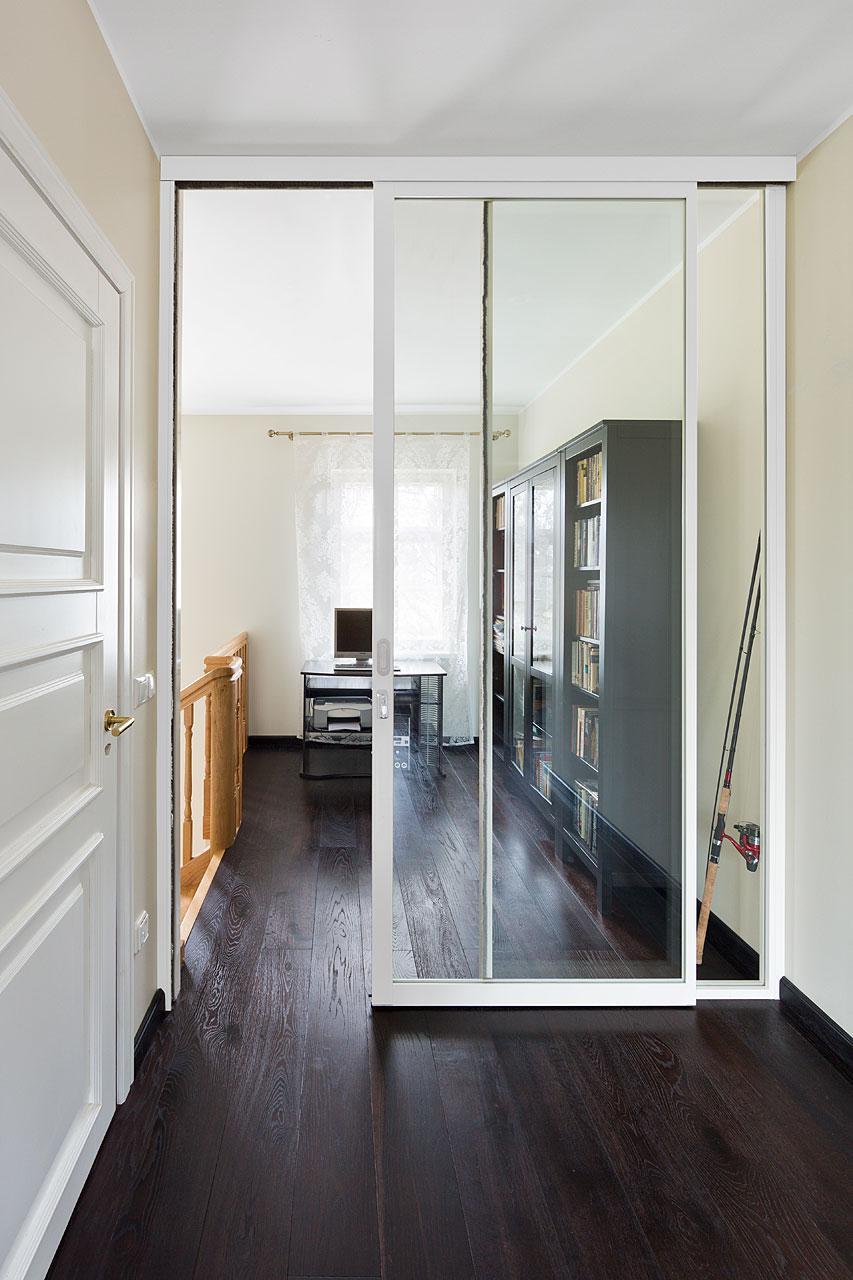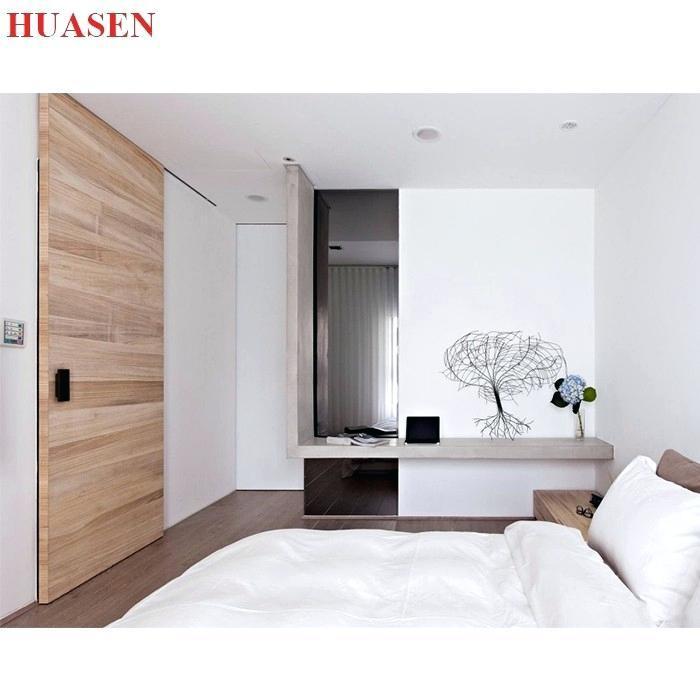The first image is the image on the left, the second image is the image on the right. Given the left and right images, does the statement "One door is glass." hold true? Answer yes or no. Yes. 